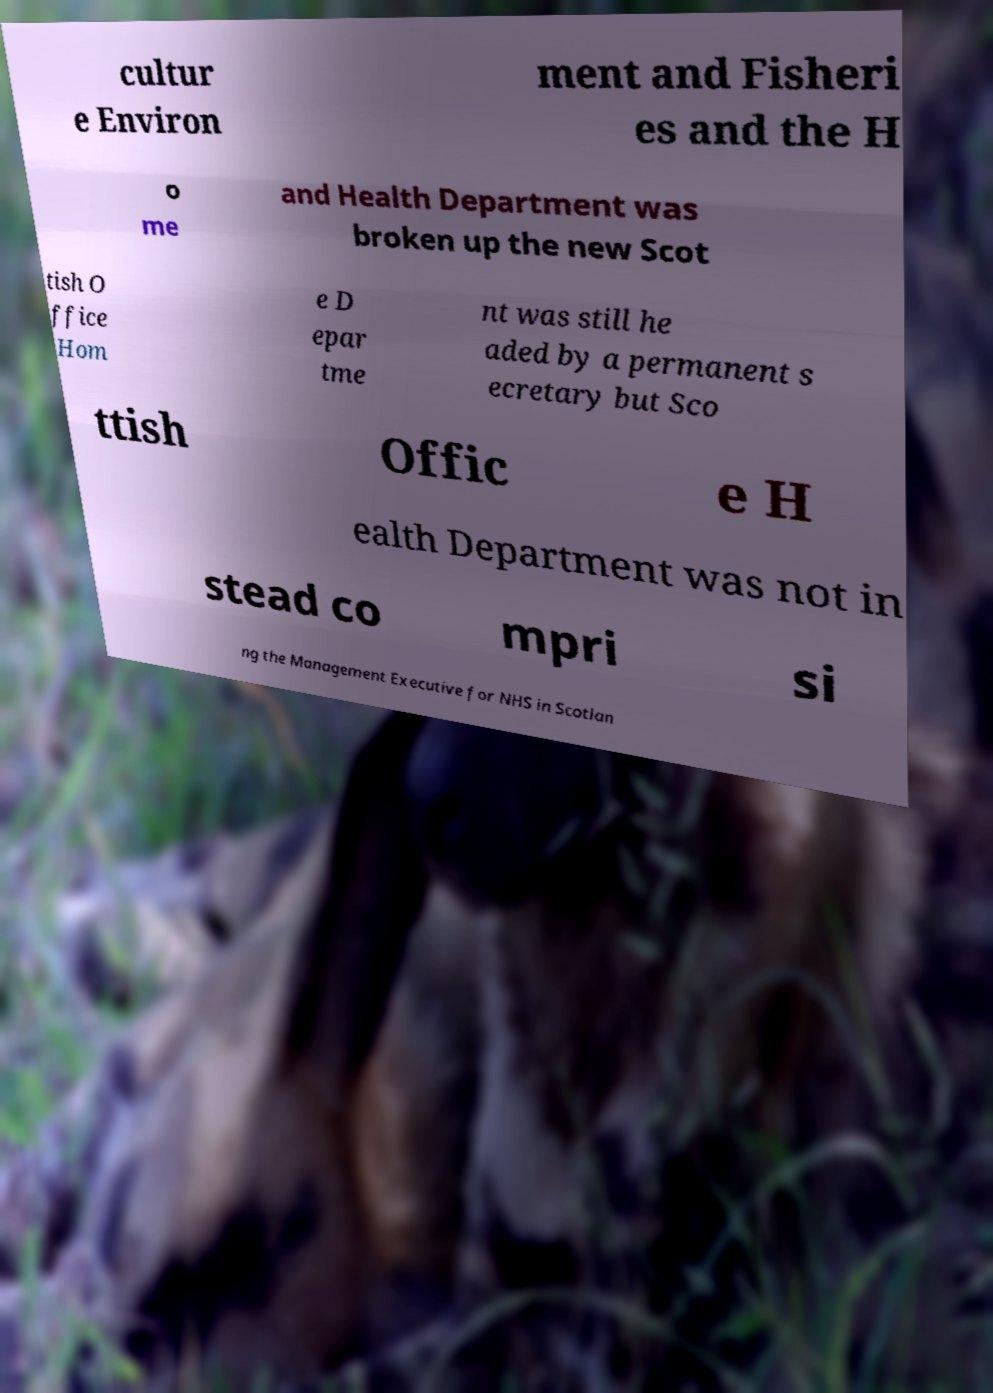Could you extract and type out the text from this image? cultur e Environ ment and Fisheri es and the H o me and Health Department was broken up the new Scot tish O ffice Hom e D epar tme nt was still he aded by a permanent s ecretary but Sco ttish Offic e H ealth Department was not in stead co mpri si ng the Management Executive for NHS in Scotlan 